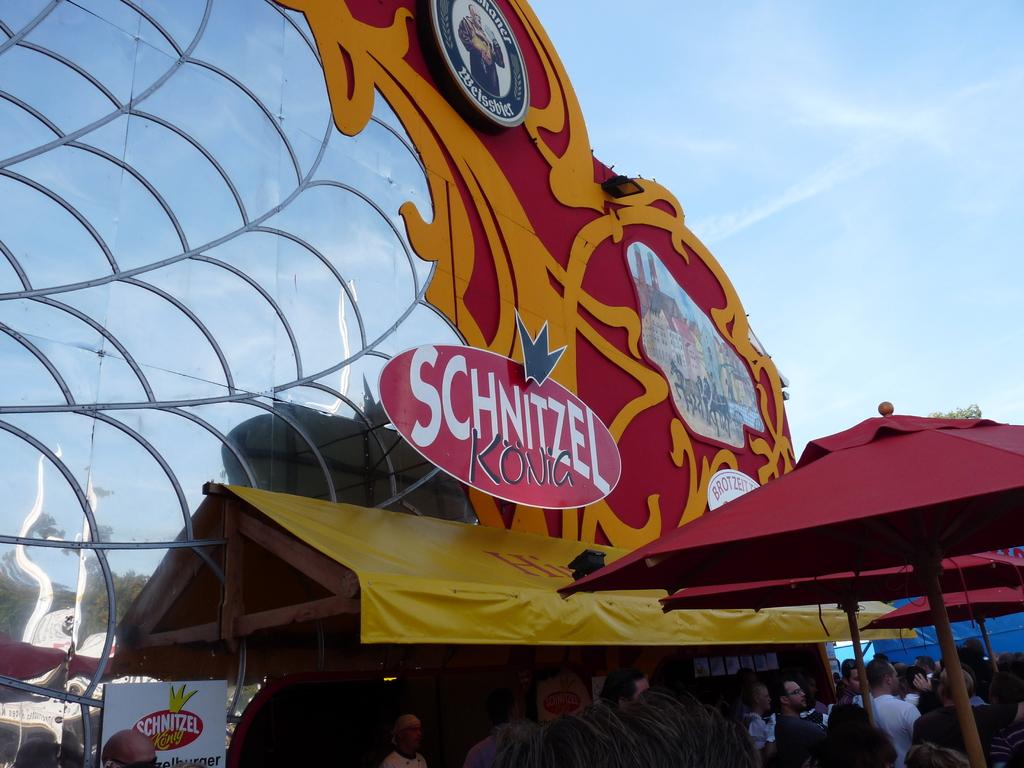Is this a carnival ride?
Your response must be concise. Unanswerable. What does it say on the ride?
Keep it short and to the point. Schnitzel konia. 